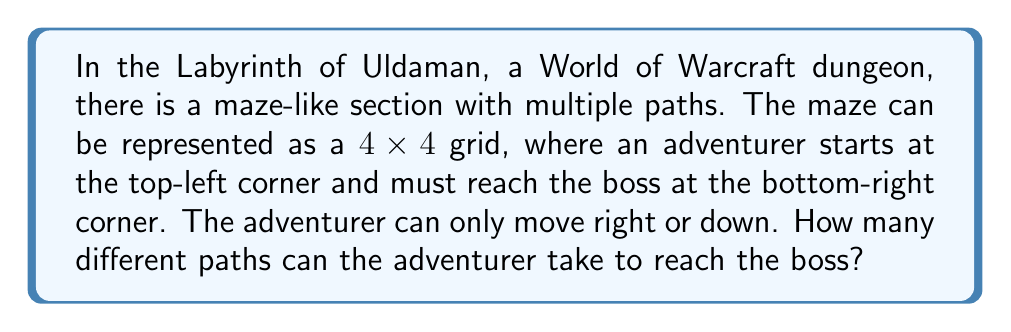Can you answer this question? Let's approach this step-by-step:

1) First, we need to understand what the question is asking. We have a $4 \times 4$ grid, and we need to go from the top-left to the bottom-right corner, only moving right or down.

2) This is a classic combinatorics problem that can be solved using the concept of lattice paths.

3) To reach the bottom-right corner from the top-left, we always need to move:
   - 3 steps right
   - 3 steps down

4) The total number of steps is always 6 (3 right + 3 down).

5) The question is essentially asking: in how many ways can we arrange 3 right moves and 3 down moves in a sequence of 6 moves?

6) This is equivalent to choosing positions for either the right moves or the down moves out of the 6 total positions.

7) We can use the combination formula:

   $$\binom{6}{3} = \frac{6!}{3!(6-3)!} = \frac{6!}{3!3!}$$

8) Let's calculate this:
   $$\frac{6 \times 5 \times 4 \times 3!}{3 \times 2 \times 1 \times 3!} = \frac{6 \times 5 \times 4}{3 \times 2 \times 1} = \frac{120}{6} = 20$$

Therefore, there are 20 different paths through the Labyrinth of Uldaman maze.
Answer: 20 